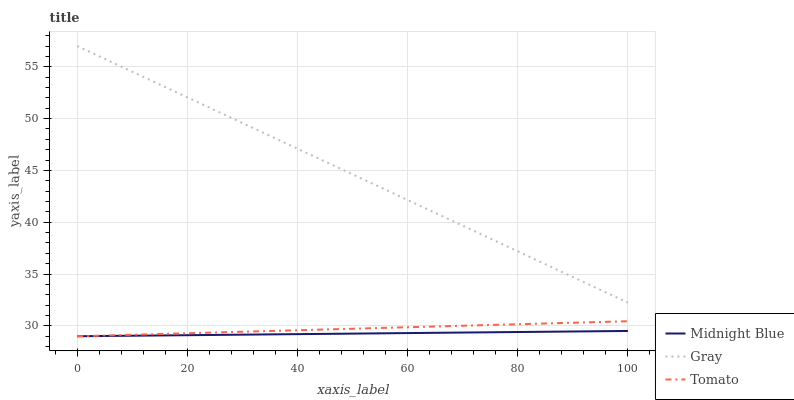Does Midnight Blue have the minimum area under the curve?
Answer yes or no. Yes. Does Gray have the maximum area under the curve?
Answer yes or no. Yes. Does Gray have the minimum area under the curve?
Answer yes or no. No. Does Midnight Blue have the maximum area under the curve?
Answer yes or no. No. Is Tomato the smoothest?
Answer yes or no. Yes. Is Gray the roughest?
Answer yes or no. Yes. Is Midnight Blue the smoothest?
Answer yes or no. No. Is Midnight Blue the roughest?
Answer yes or no. No. Does Tomato have the lowest value?
Answer yes or no. Yes. Does Gray have the lowest value?
Answer yes or no. No. Does Gray have the highest value?
Answer yes or no. Yes. Does Midnight Blue have the highest value?
Answer yes or no. No. Is Tomato less than Gray?
Answer yes or no. Yes. Is Gray greater than Tomato?
Answer yes or no. Yes. Does Midnight Blue intersect Tomato?
Answer yes or no. Yes. Is Midnight Blue less than Tomato?
Answer yes or no. No. Is Midnight Blue greater than Tomato?
Answer yes or no. No. Does Tomato intersect Gray?
Answer yes or no. No. 